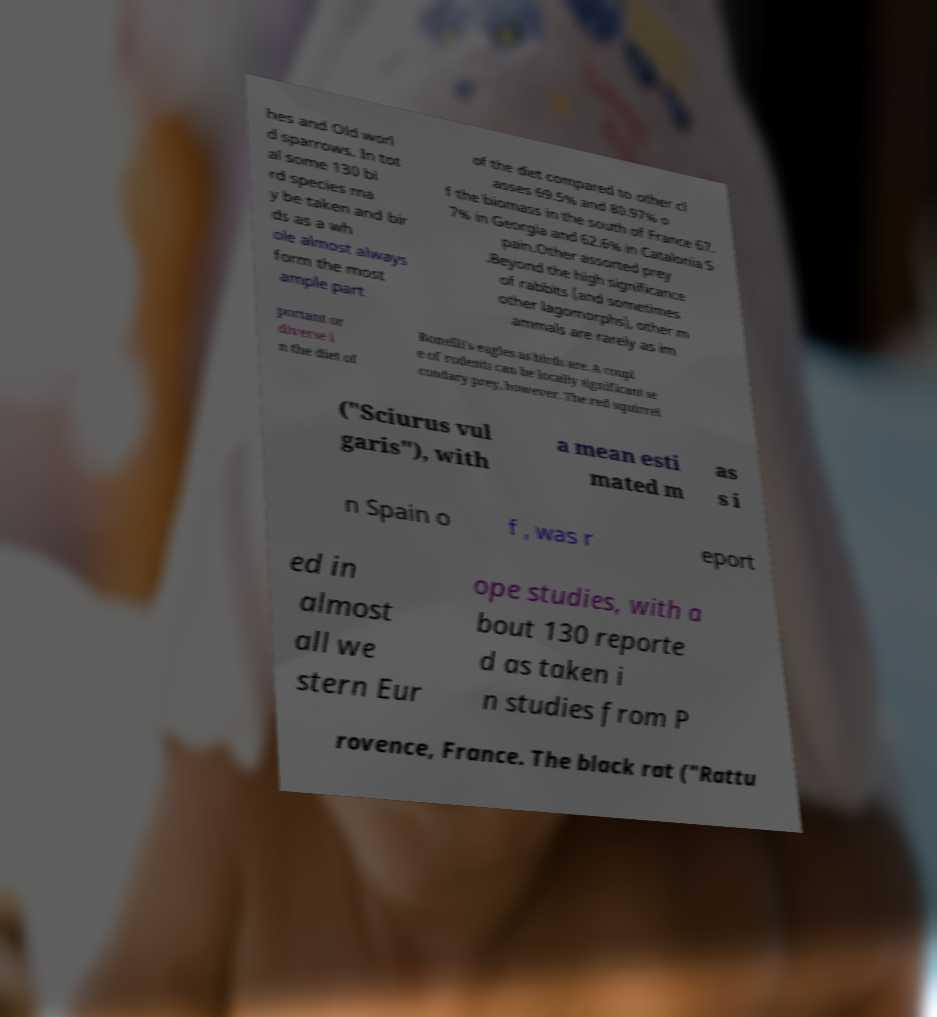There's text embedded in this image that I need extracted. Can you transcribe it verbatim? hes and Old worl d sparrows. In tot al some 130 bi rd species ma y be taken and bir ds as a wh ole almost always form the most ample part of the diet compared to other cl asses 69.5% and 80.97% o f the biomass in the south of France 67. 7% in Georgia and 62.6% in Catalonia S pain.Other assorted prey .Beyond the high significance of rabbits (and sometimes other lagomorphs), other m ammals are rarely as im portant or diverse i n the diet of Bonelli's eagles as birds are. A coupl e of rodents can be locally significant se condary prey, however. The red squirrel ("Sciurus vul garis"), with a mean esti mated m as s i n Spain o f , was r eport ed in almost all we stern Eur ope studies, with a bout 130 reporte d as taken i n studies from P rovence, France. The black rat ("Rattu 